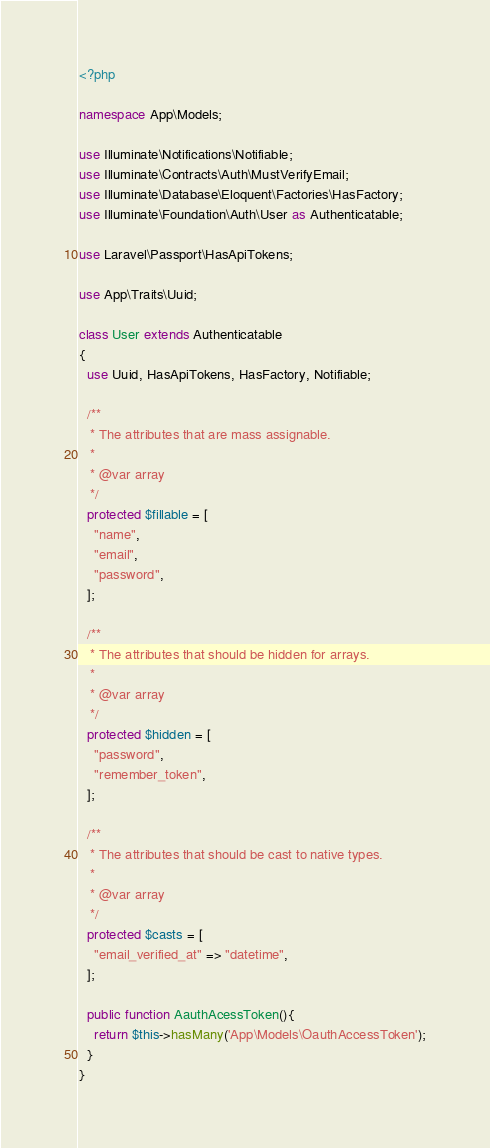<code> <loc_0><loc_0><loc_500><loc_500><_PHP_><?php

namespace App\Models;

use Illuminate\Notifications\Notifiable;
use Illuminate\Contracts\Auth\MustVerifyEmail;
use Illuminate\Database\Eloquent\Factories\HasFactory;
use Illuminate\Foundation\Auth\User as Authenticatable;

use Laravel\Passport\HasApiTokens;

use App\Traits\Uuid;

class User extends Authenticatable
{
  use Uuid, HasApiTokens, HasFactory, Notifiable;

  /**
   * The attributes that are mass assignable.
   *
   * @var array
   */
  protected $fillable = [
    "name",
    "email",
    "password",
  ];

  /**
   * The attributes that should be hidden for arrays.
   *
   * @var array
   */
  protected $hidden = [
    "password",
    "remember_token",
  ];

  /**
   * The attributes that should be cast to native types.
   *
   * @var array
   */
  protected $casts = [
    "email_verified_at" => "datetime",
  ];

  public function AauthAcessToken(){
    return $this->hasMany('App\Models\OauthAccessToken');
  }
}
</code> 